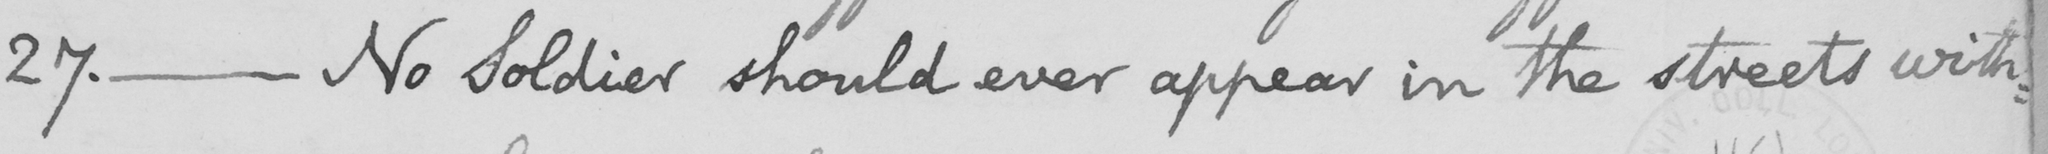What does this handwritten line say? 27. _ No soldier should ever appear in the streets with: 